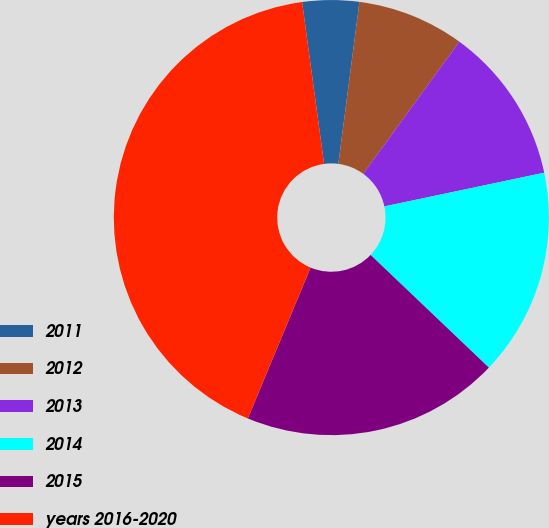<chart> <loc_0><loc_0><loc_500><loc_500><pie_chart><fcel>2011<fcel>2012<fcel>2013<fcel>2014<fcel>2015<fcel>years 2016-2020<nl><fcel>4.21%<fcel>7.95%<fcel>11.68%<fcel>15.42%<fcel>19.16%<fcel>41.58%<nl></chart> 